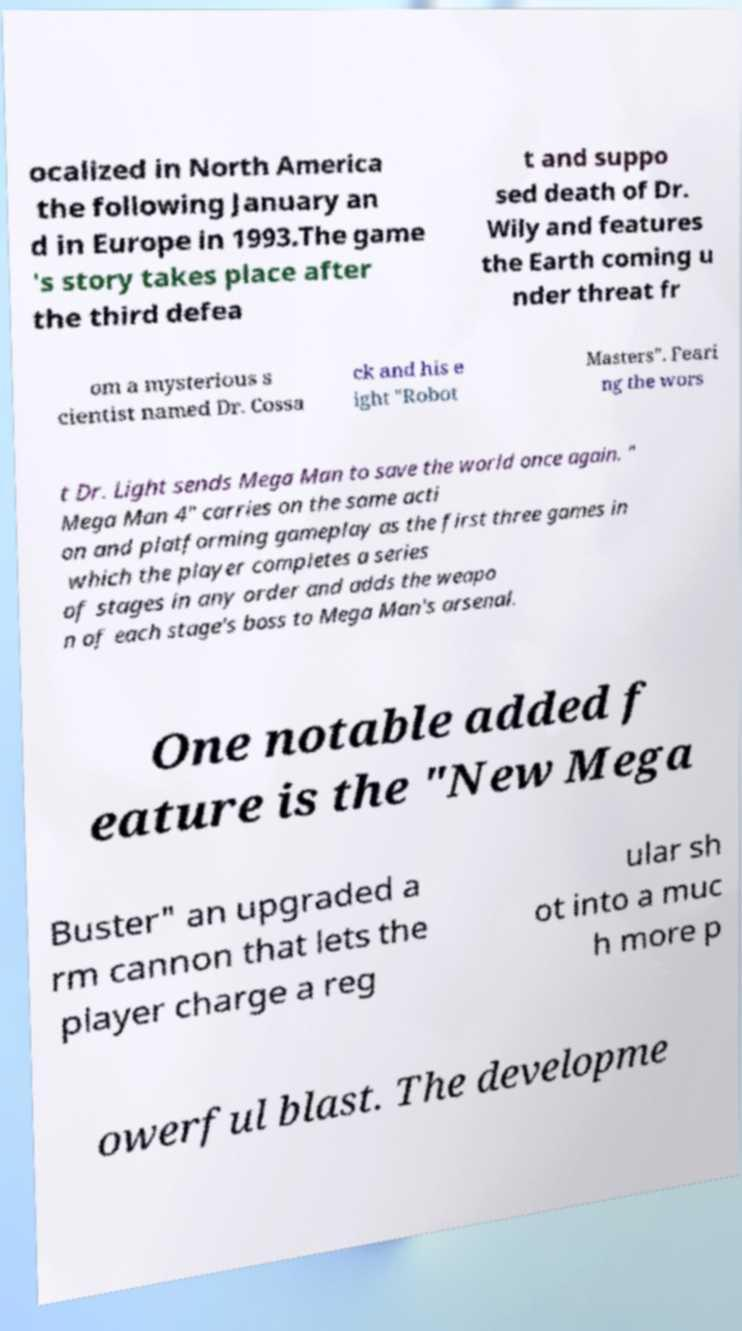Could you extract and type out the text from this image? ocalized in North America the following January an d in Europe in 1993.The game 's story takes place after the third defea t and suppo sed death of Dr. Wily and features the Earth coming u nder threat fr om a mysterious s cientist named Dr. Cossa ck and his e ight "Robot Masters". Feari ng the wors t Dr. Light sends Mega Man to save the world once again. " Mega Man 4" carries on the same acti on and platforming gameplay as the first three games in which the player completes a series of stages in any order and adds the weapo n of each stage's boss to Mega Man's arsenal. One notable added f eature is the "New Mega Buster" an upgraded a rm cannon that lets the player charge a reg ular sh ot into a muc h more p owerful blast. The developme 